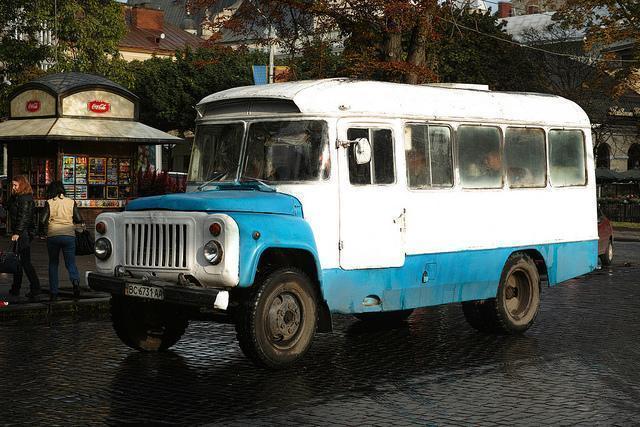What part of the bus needs good traction to ride safely?
Select the correct answer and articulate reasoning with the following format: 'Answer: answer
Rationale: rationale.'
Options: Tires, motor, door, windows. Answer: tires.
Rationale: It's important that the tires hug the road. 